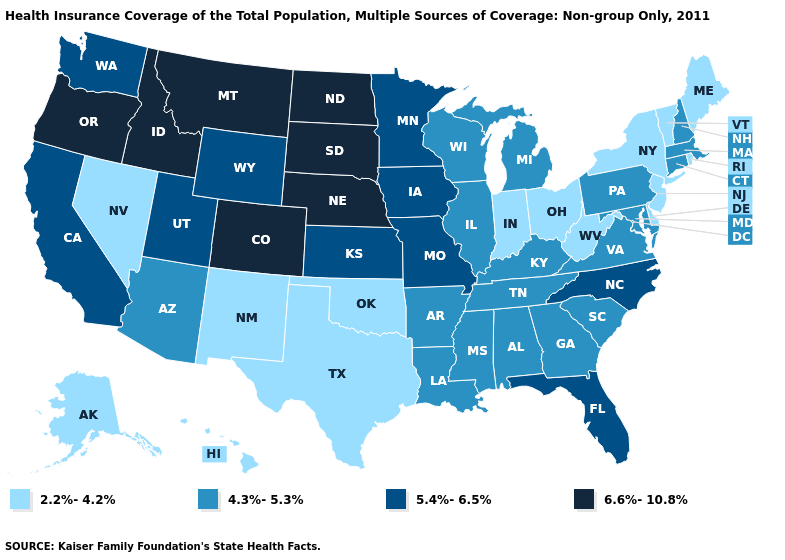What is the highest value in the USA?
Short answer required. 6.6%-10.8%. Name the states that have a value in the range 6.6%-10.8%?
Answer briefly. Colorado, Idaho, Montana, Nebraska, North Dakota, Oregon, South Dakota. Name the states that have a value in the range 5.4%-6.5%?
Keep it brief. California, Florida, Iowa, Kansas, Minnesota, Missouri, North Carolina, Utah, Washington, Wyoming. What is the highest value in the West ?
Answer briefly. 6.6%-10.8%. Which states have the lowest value in the Northeast?
Be succinct. Maine, New Jersey, New York, Rhode Island, Vermont. Does Hawaii have the highest value in the West?
Be succinct. No. Which states have the lowest value in the Northeast?
Write a very short answer. Maine, New Jersey, New York, Rhode Island, Vermont. Does the map have missing data?
Keep it brief. No. Name the states that have a value in the range 2.2%-4.2%?
Answer briefly. Alaska, Delaware, Hawaii, Indiana, Maine, Nevada, New Jersey, New Mexico, New York, Ohio, Oklahoma, Rhode Island, Texas, Vermont, West Virginia. Is the legend a continuous bar?
Answer briefly. No. Name the states that have a value in the range 5.4%-6.5%?
Be succinct. California, Florida, Iowa, Kansas, Minnesota, Missouri, North Carolina, Utah, Washington, Wyoming. Name the states that have a value in the range 4.3%-5.3%?
Write a very short answer. Alabama, Arizona, Arkansas, Connecticut, Georgia, Illinois, Kentucky, Louisiana, Maryland, Massachusetts, Michigan, Mississippi, New Hampshire, Pennsylvania, South Carolina, Tennessee, Virginia, Wisconsin. Name the states that have a value in the range 5.4%-6.5%?
Keep it brief. California, Florida, Iowa, Kansas, Minnesota, Missouri, North Carolina, Utah, Washington, Wyoming. Name the states that have a value in the range 4.3%-5.3%?
Quick response, please. Alabama, Arizona, Arkansas, Connecticut, Georgia, Illinois, Kentucky, Louisiana, Maryland, Massachusetts, Michigan, Mississippi, New Hampshire, Pennsylvania, South Carolina, Tennessee, Virginia, Wisconsin. What is the value of Arkansas?
Be succinct. 4.3%-5.3%. 